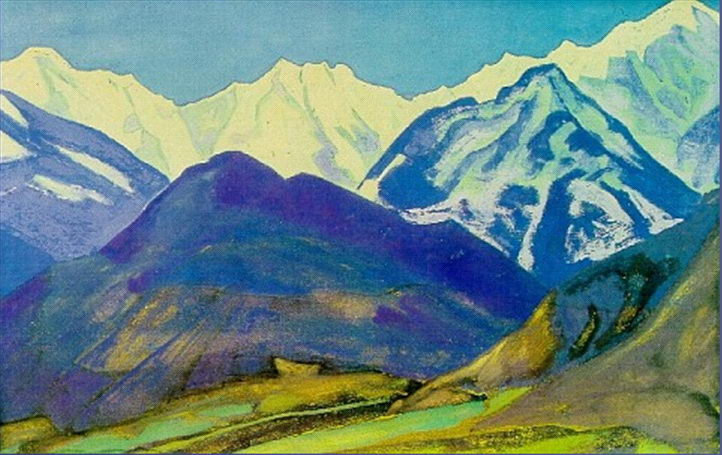What could the choice of colors tell us about the mood the artist is trying to convey? The artist's choice of vivid and contrasting colors in the mountain landscape likely suggests a mood of vibrancy and dynamism. The use of cool blues and purples alongside brighter greens and yellows might represent the varying and dynamic emotions associated with nature, from calmness and serenity to the vivid vitality of the natural world. This could be a visual technique to evoke a sense of awe and profound connection with the landscape. 